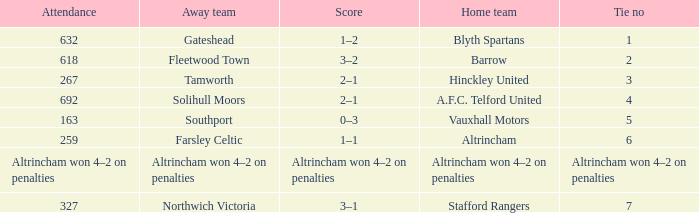What was the score when there were 7 draws? 3–1. 